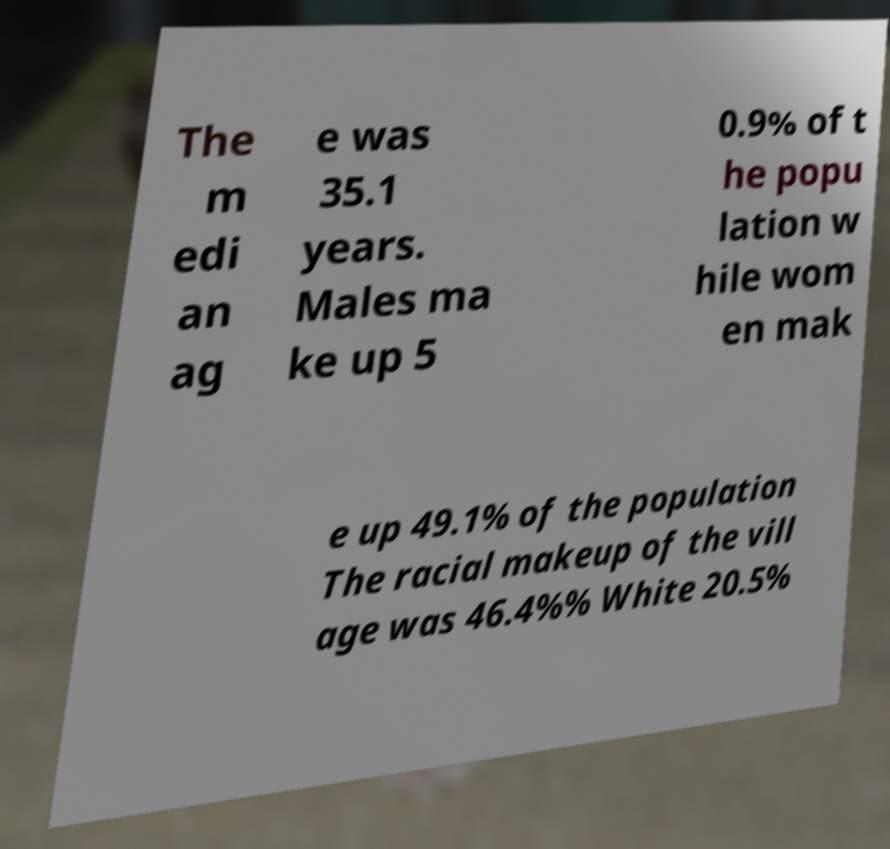Please identify and transcribe the text found in this image. The m edi an ag e was 35.1 years. Males ma ke up 5 0.9% of t he popu lation w hile wom en mak e up 49.1% of the population The racial makeup of the vill age was 46.4%% White 20.5% 